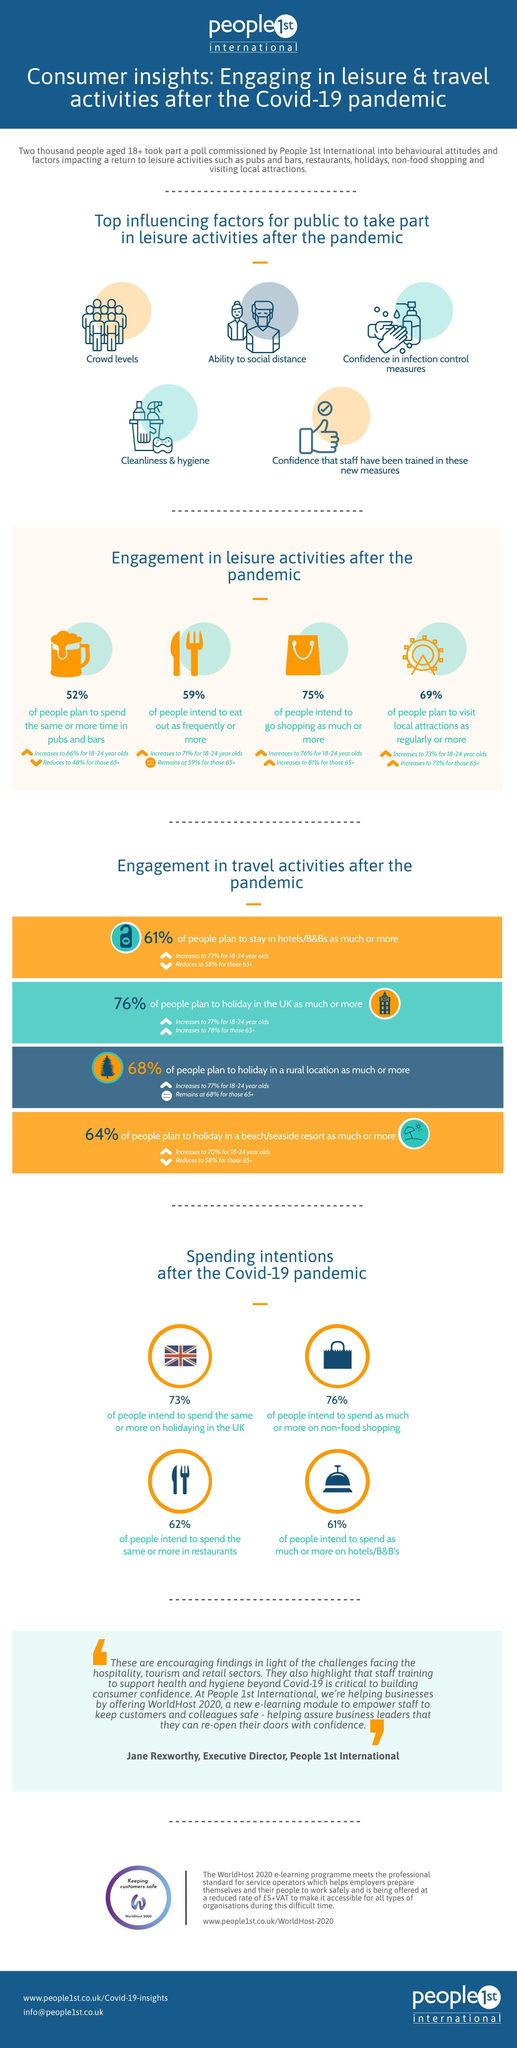What percentage of people intend to go for more shopping after the Covid-19 pandemic in the U.K.?
Answer the question with a short phrase. 75% What percentage of people intend to spend more on non-food shopping after the Covid-19 pandemic in the U.K.? 76% What percentage of people plan to visit local attractions as regularly or more after the Covid-19 pandemic in the U.K.? 69% What percentage of people intend to spend the same or more in restaurants after the Covid-19 pandemic in the U.K.? 62% What percentage of people in the U.K intend to eat out more frequently after the Covid-19 pandemic? 59% 